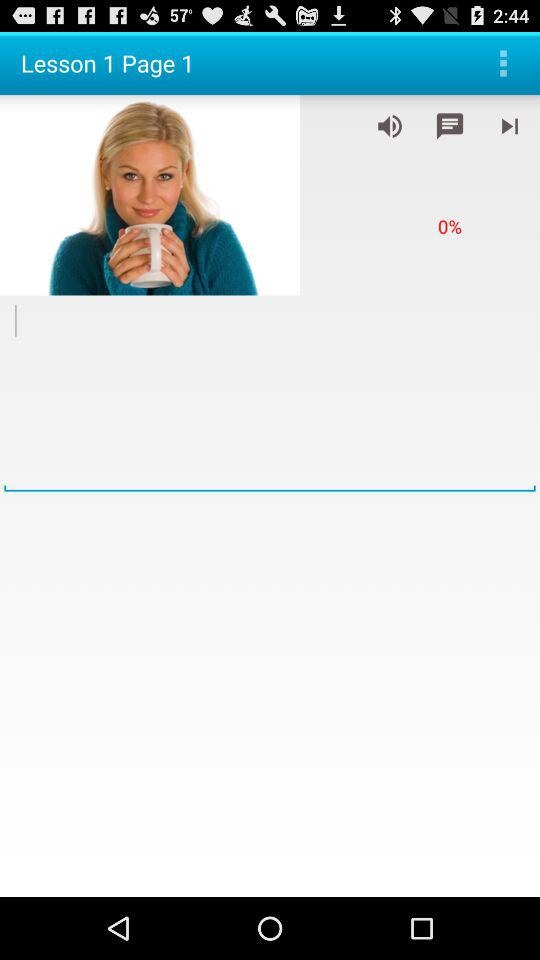How many lessons are available? There is 1 lesson available. 